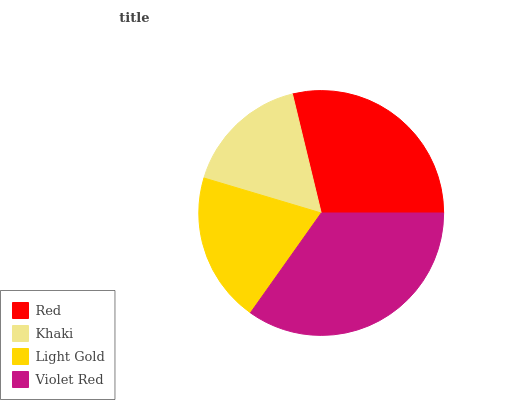Is Khaki the minimum?
Answer yes or no. Yes. Is Violet Red the maximum?
Answer yes or no. Yes. Is Light Gold the minimum?
Answer yes or no. No. Is Light Gold the maximum?
Answer yes or no. No. Is Light Gold greater than Khaki?
Answer yes or no. Yes. Is Khaki less than Light Gold?
Answer yes or no. Yes. Is Khaki greater than Light Gold?
Answer yes or no. No. Is Light Gold less than Khaki?
Answer yes or no. No. Is Red the high median?
Answer yes or no. Yes. Is Light Gold the low median?
Answer yes or no. Yes. Is Khaki the high median?
Answer yes or no. No. Is Khaki the low median?
Answer yes or no. No. 